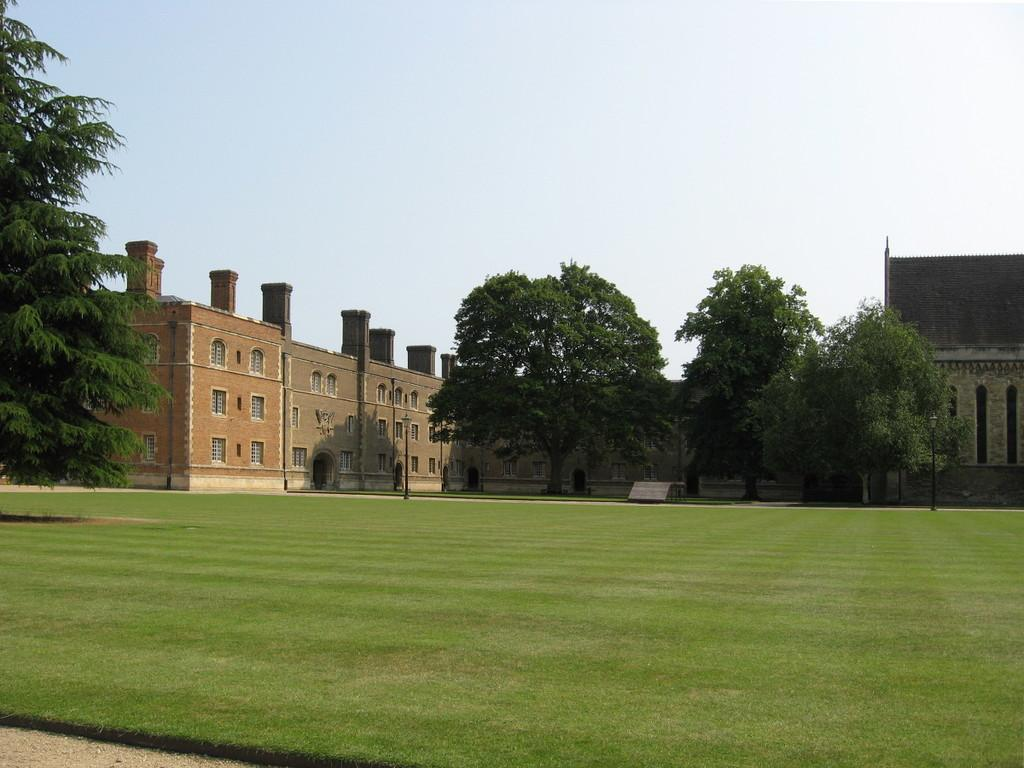What type of ground covering is visible in the image? The ground in the image is covered with grass. What type of vegetation can be seen in the image? There are trees visible in the image. What type of structures are present in the image? There are buildings in the image. What type of jar can be seen hanging from the trees in the image? There is no jar present in the image, and therefore no such object can be observed hanging from the trees. 